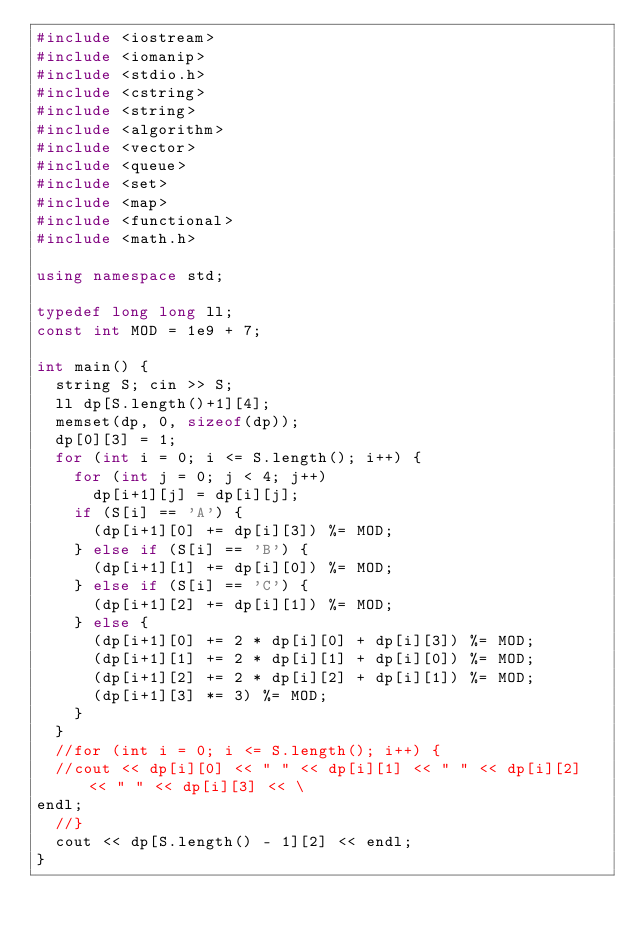Convert code to text. <code><loc_0><loc_0><loc_500><loc_500><_C++_>#include <iostream>
#include <iomanip>
#include <stdio.h>
#include <cstring>
#include <string>
#include <algorithm>
#include <vector>
#include <queue>
#include <set>
#include <map>
#include <functional>
#include <math.h>

using namespace std;

typedef long long ll;
const int MOD = 1e9 + 7;

int main() {
  string S; cin >> S;
  ll dp[S.length()+1][4];
  memset(dp, 0, sizeof(dp));
  dp[0][3] = 1;
  for (int i = 0; i <= S.length(); i++) {
    for (int j = 0; j < 4; j++)
      dp[i+1][j] = dp[i][j];
    if (S[i] == 'A') {
      (dp[i+1][0] += dp[i][3]) %= MOD;
    } else if (S[i] == 'B') {
      (dp[i+1][1] += dp[i][0]) %= MOD;
    } else if (S[i] == 'C') {
      (dp[i+1][2] += dp[i][1]) %= MOD;
    } else {
      (dp[i+1][0] += 2 * dp[i][0] + dp[i][3]) %= MOD;
      (dp[i+1][1] += 2 * dp[i][1] + dp[i][0]) %= MOD;
      (dp[i+1][2] += 2 * dp[i][2] + dp[i][1]) %= MOD;
      (dp[i+1][3] *= 3) %= MOD;
    }
  }
  //for (int i = 0; i <= S.length(); i++) {                                       
  //cout << dp[i][0] << " " << dp[i][1] << " " << dp[i][2] << " " << dp[i][3] << \
endl;                                                                             
  //}                                                                             
  cout << dp[S.length() - 1][2] << endl;
}
</code> 